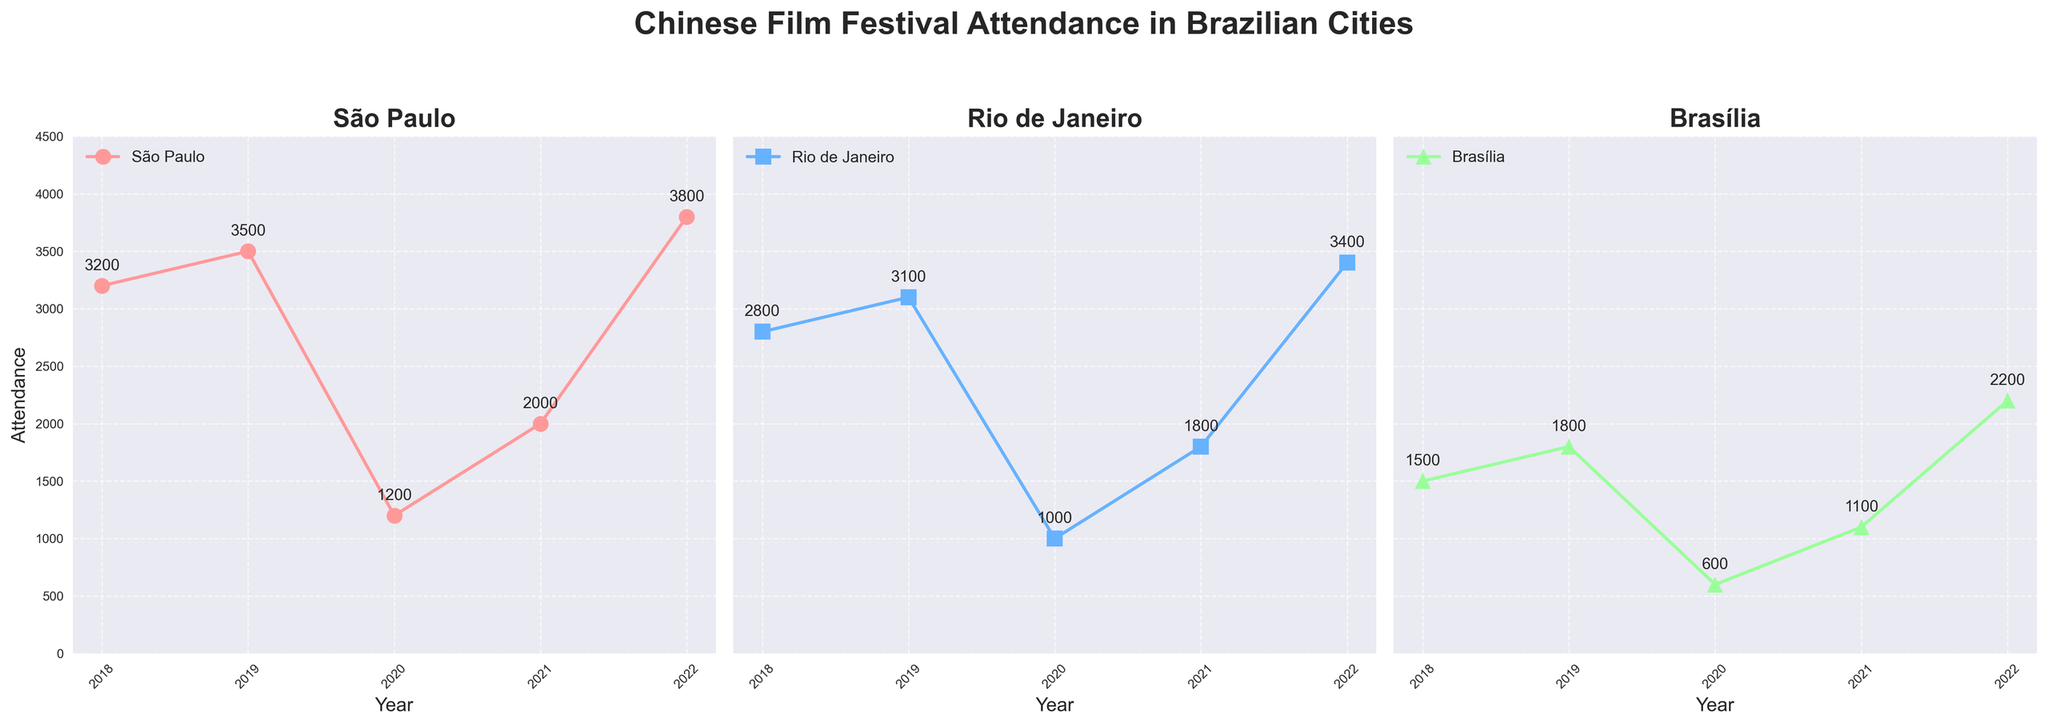What is the title of the figure? The title is located at the top of the figure, usually in a larger or bold font. It serves as a brief summary of what the figure represents. The title of this figure is "Chinese Film Festival Attendance in Brazilian Cities".
Answer: Chinese Film Festival Attendance in Brazilian Cities How many cities are shown in the figure? Identify each distinct subplot dedicated to different cities. Given that each subplot represents a different city, count these subplots.
Answer: 3 Which city had the highest attendance in 2022? Locate the data points for 2022 in each subplot. Compare the attendance figures for each city in 2022 to find the highest one. São Paulo's Shanghai Film Week had the highest attendance in 2022 with 3800 attendees.
Answer: São Paulo What is the trend of film festival attendance in Brasília from 2018 to 2022? Focus on the subplot dedicated to Brasília. Observe the changes in data points over the years and note whether the attendance is increasing, decreasing, or remaining constant. Attendance in Brasília decreased from 2018 to 2020, then increased from 2021 to 2022.
Answer: Decreasing then increasing Which city experienced the sharpest drop in attendance from 2019 to 2020? Identify the data points for 2019 and 2020 in each subplot. Calculate the difference in attendance for each city between these years and compare them to find the sharpest drop. São Paulo experienced the sharpest drop with a decrease from 3500 to 1200.
Answer: São Paulo What was the average attendance for Rio de Janeiro in the past five years? Gather all attendance data points for Rio de Janeiro from 2018 to 2022. Sum these values and divide by the number of years to find the average. The sums: 2800 + 3100 + 1000 + 1800 + 3400 = 12100. Divide by 5 to get the average: 12100 / 5 = 2420.
Answer: 2420 How did attendance change from 2020 to 2021 in São Paulo? Observe the data points for São Paulo in 2020 and 2021. Note the attendance numbers and calculate the difference between these years. Attendance in São Paulo increased from 1200 in 2020 to 2000 in 2021.
Answer: Increased Compare the overall trend of attendance in São Paulo and Rio de Janeiro from 2018 to 2022. Look at the data points for both cities over the specified years. Notice how the attendance figures change annually. São Paulo had a peak in 2019, a significant drop in 2020, then increased again up to 2022. Rio de Janeiro followed a similar pattern with a peak in 2019, a drop in 2020, and a rise up to 2022.
Answer: Similar with peaks and drops 